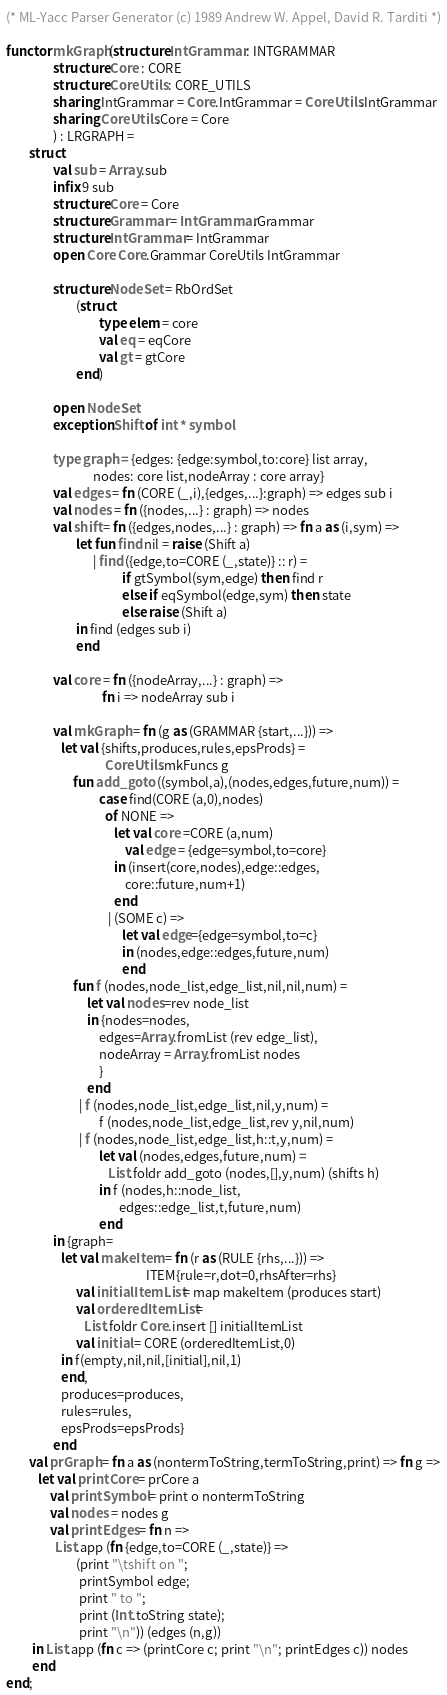Convert code to text. <code><loc_0><loc_0><loc_500><loc_500><_SML_>(* ML-Yacc Parser Generator (c) 1989 Andrew W. Appel, David R. Tarditi *)

functor mkGraph(structure IntGrammar : INTGRAMMAR
                structure Core : CORE
                structure CoreUtils : CORE_UTILS
                sharing IntGrammar = Core.IntGrammar = CoreUtils.IntGrammar
                sharing CoreUtils.Core = Core
                ) : LRGRAPH =
        struct
                val sub = Array.sub
                infix 9 sub
                structure Core = Core
                structure Grammar = IntGrammar.Grammar
                structure IntGrammar = IntGrammar
                open Core Core.Grammar CoreUtils IntGrammar

                structure NodeSet = RbOrdSet
                        (struct
                                type elem = core
                                val eq = eqCore
                                val gt = gtCore
                        end)

                open NodeSet
                exception Shift of int * symbol

                type graph = {edges: {edge:symbol,to:core} list array,
                              nodes: core list,nodeArray : core array}
                val edges = fn (CORE (_,i),{edges,...}:graph) => edges sub i
                val nodes = fn ({nodes,...} : graph) => nodes
                val shift = fn ({edges,nodes,...} : graph) => fn a as (i,sym) =>
                        let fun find nil = raise (Shift a)
                              | find ({edge,to=CORE (_,state)} :: r) =
                                        if gtSymbol(sym,edge) then find r
                                        else if eqSymbol(edge,sym) then state
                                        else raise (Shift a)
                        in find (edges sub i)
                        end

                val core = fn ({nodeArray,...} : graph) =>
                                 fn i => nodeArray sub i

                val mkGraph = fn (g as (GRAMMAR {start,...})) =>
                   let val {shifts,produces,rules,epsProds} =
                                  CoreUtils.mkFuncs g
                       fun add_goto ((symbol,a),(nodes,edges,future,num)) =
                                case find(CORE (a,0),nodes)
                                  of NONE =>
                                     let val core =CORE (a,num)
                                         val edge = {edge=symbol,to=core}
                                     in (insert(core,nodes),edge::edges,
                                         core::future,num+1)
                                     end
                                   | (SOME c) =>
                                        let val edge={edge=symbol,to=c}
                                        in (nodes,edge::edges,future,num)
                                        end
                       fun f (nodes,node_list,edge_list,nil,nil,num) =
                            let val nodes=rev node_list
                            in {nodes=nodes,
                                edges=Array.fromList (rev edge_list),
                                nodeArray = Array.fromList nodes
                                }
                            end
                         | f (nodes,node_list,edge_list,nil,y,num) =
                                f (nodes,node_list,edge_list,rev y,nil,num)
                         | f (nodes,node_list,edge_list,h::t,y,num) =
                                let val (nodes,edges,future,num) =
                                   List.foldr add_goto (nodes,[],y,num) (shifts h)
                                in f (nodes,h::node_list,
                                       edges::edge_list,t,future,num)
                                end
                in {graph=
                   let val makeItem = fn (r as (RULE {rhs,...})) =>
                                                ITEM{rule=r,dot=0,rhsAfter=rhs}
                        val initialItemList = map makeItem (produces start)
                        val orderedItemList =
                           List.foldr Core.insert [] initialItemList
                        val initial = CORE (orderedItemList,0)
                   in f(empty,nil,nil,[initial],nil,1)
                   end,
                   produces=produces,
                   rules=rules,
                   epsProds=epsProds}
                end
        val prGraph = fn a as (nontermToString,termToString,print) => fn g =>
           let val printCore = prCore a
               val printSymbol = print o nontermToString
               val nodes = nodes g
               val printEdges = fn n =>
                 List.app (fn {edge,to=CORE (_,state)} =>
                        (print "\tshift on ";
                         printSymbol edge;
                         print " to ";
                         print (Int.toString state);
                         print "\n")) (edges (n,g))
         in List.app (fn c => (printCore c; print "\n"; printEdges c)) nodes
         end
end;
</code> 